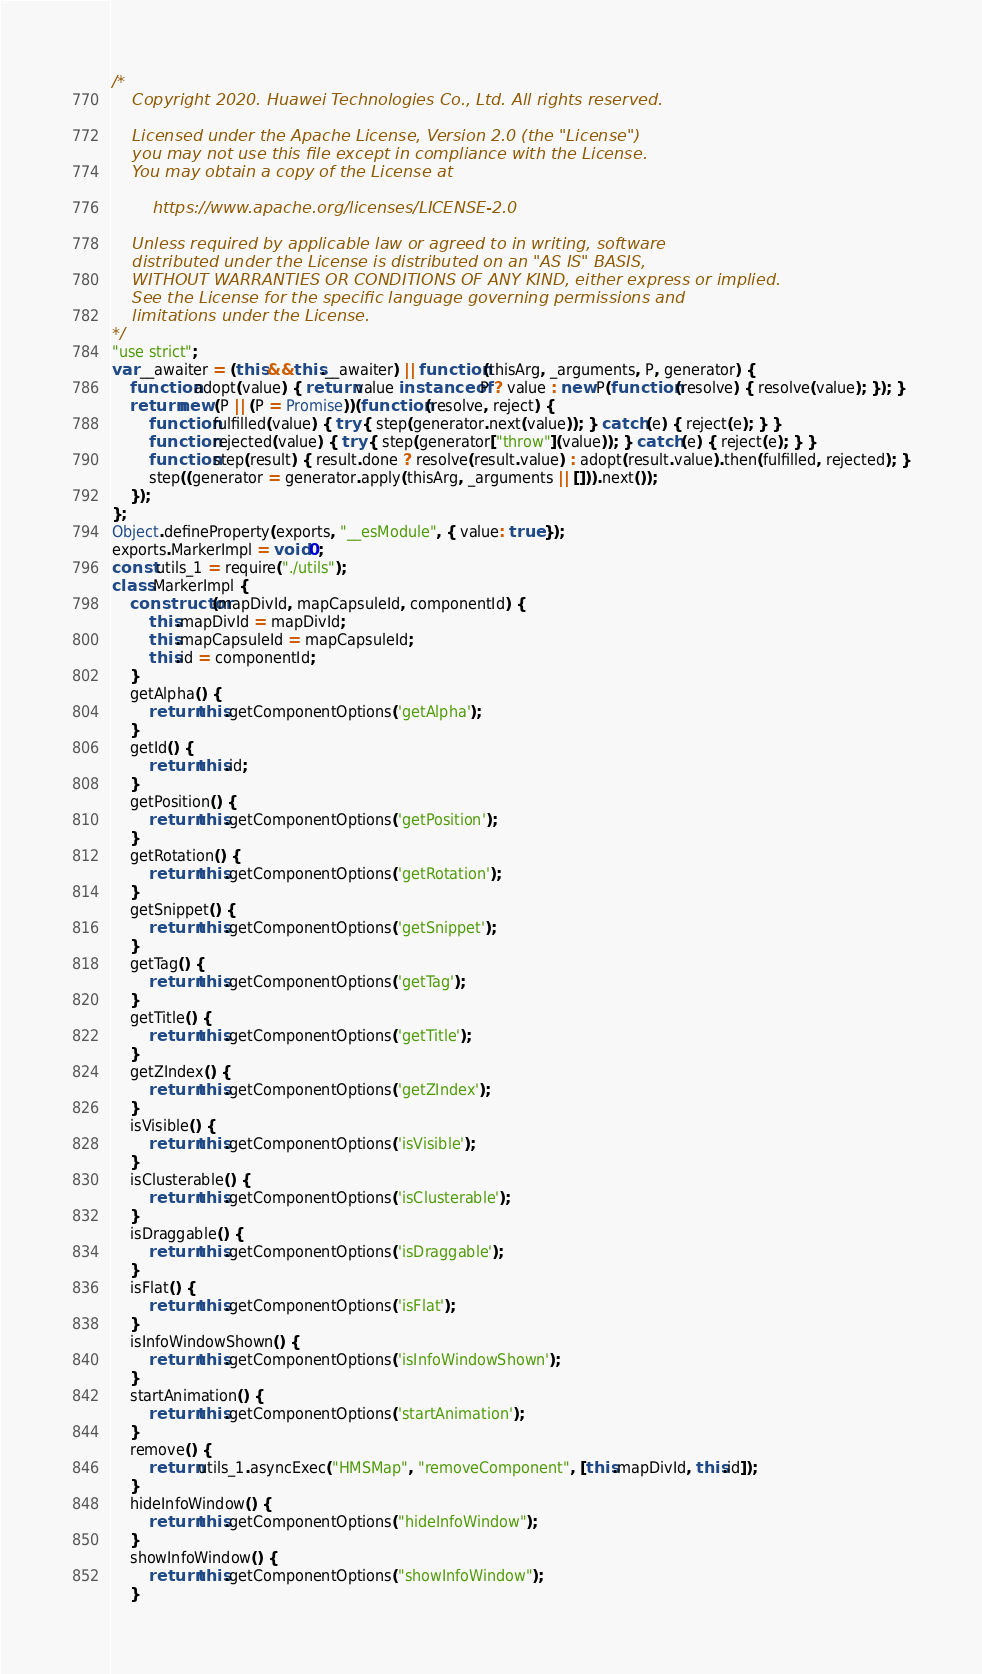Convert code to text. <code><loc_0><loc_0><loc_500><loc_500><_JavaScript_>/*
    Copyright 2020. Huawei Technologies Co., Ltd. All rights reserved.

    Licensed under the Apache License, Version 2.0 (the "License")
    you may not use this file except in compliance with the License.
    You may obtain a copy of the License at

        https://www.apache.org/licenses/LICENSE-2.0

    Unless required by applicable law or agreed to in writing, software
    distributed under the License is distributed on an "AS IS" BASIS,
    WITHOUT WARRANTIES OR CONDITIONS OF ANY KIND, either express or implied.
    See the License for the specific language governing permissions and
    limitations under the License.
*/
"use strict";
var __awaiter = (this && this.__awaiter) || function (thisArg, _arguments, P, generator) {
    function adopt(value) { return value instanceof P ? value : new P(function (resolve) { resolve(value); }); }
    return new (P || (P = Promise))(function (resolve, reject) {
        function fulfilled(value) { try { step(generator.next(value)); } catch (e) { reject(e); } }
        function rejected(value) { try { step(generator["throw"](value)); } catch (e) { reject(e); } }
        function step(result) { result.done ? resolve(result.value) : adopt(result.value).then(fulfilled, rejected); }
        step((generator = generator.apply(thisArg, _arguments || [])).next());
    });
};
Object.defineProperty(exports, "__esModule", { value: true });
exports.MarkerImpl = void 0;
const utils_1 = require("./utils");
class MarkerImpl {
    constructor(mapDivId, mapCapsuleId, componentId) {
        this.mapDivId = mapDivId;
        this.mapCapsuleId = mapCapsuleId;
        this.id = componentId;
    }
    getAlpha() {
        return this.getComponentOptions('getAlpha');
    }
    getId() {
        return this.id;
    }
    getPosition() {
        return this.getComponentOptions('getPosition');
    }
    getRotation() {
        return this.getComponentOptions('getRotation');
    }
    getSnippet() {
        return this.getComponentOptions('getSnippet');
    }
    getTag() {
        return this.getComponentOptions('getTag');
    }
    getTitle() {
        return this.getComponentOptions('getTitle');
    }
    getZIndex() {
        return this.getComponentOptions('getZIndex');
    }
    isVisible() {
        return this.getComponentOptions('isVisible');
    }
    isClusterable() {
        return this.getComponentOptions('isClusterable');
    }
    isDraggable() {
        return this.getComponentOptions('isDraggable');
    }
    isFlat() {
        return this.getComponentOptions('isFlat');
    }
    isInfoWindowShown() {
        return this.getComponentOptions('isInfoWindowShown');
    }
    startAnimation() {
        return this.getComponentOptions('startAnimation');
    }
    remove() {
        return utils_1.asyncExec("HMSMap", "removeComponent", [this.mapDivId, this.id]);
    }
    hideInfoWindow() {
        return this.getComponentOptions("hideInfoWindow");
    }
    showInfoWindow() {
        return this.getComponentOptions("showInfoWindow");
    }</code> 